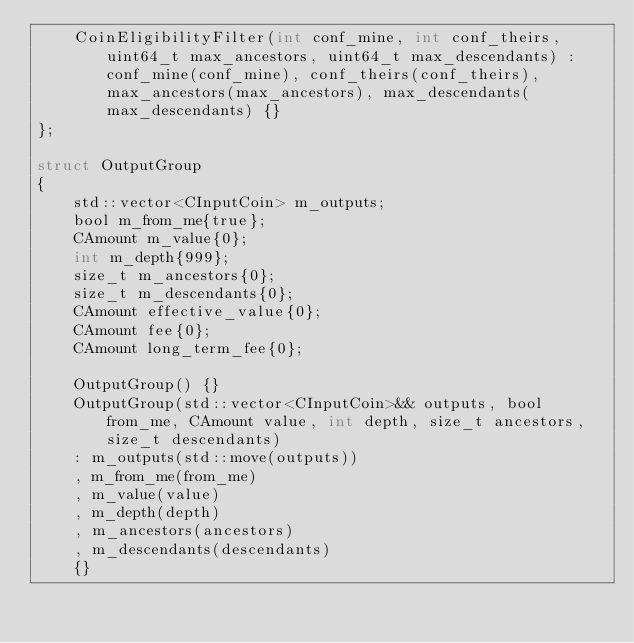Convert code to text. <code><loc_0><loc_0><loc_500><loc_500><_C_>    CoinEligibilityFilter(int conf_mine, int conf_theirs, uint64_t max_ancestors, uint64_t max_descendants) : conf_mine(conf_mine), conf_theirs(conf_theirs), max_ancestors(max_ancestors), max_descendants(max_descendants) {}
};

struct OutputGroup
{
    std::vector<CInputCoin> m_outputs;
    bool m_from_me{true};
    CAmount m_value{0};
    int m_depth{999};
    size_t m_ancestors{0};
    size_t m_descendants{0};
    CAmount effective_value{0};
    CAmount fee{0};
    CAmount long_term_fee{0};

    OutputGroup() {}
    OutputGroup(std::vector<CInputCoin>&& outputs, bool from_me, CAmount value, int depth, size_t ancestors, size_t descendants)
    : m_outputs(std::move(outputs))
    , m_from_me(from_me)
    , m_value(value)
    , m_depth(depth)
    , m_ancestors(ancestors)
    , m_descendants(descendants)
    {}</code> 